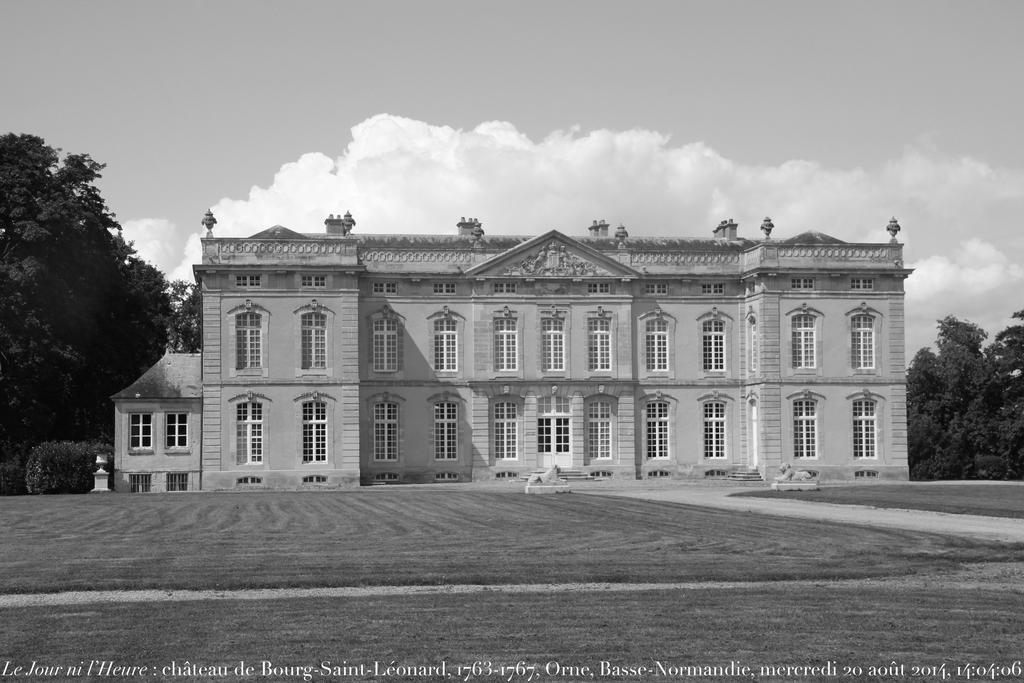How would you summarize this image in a sentence or two? In this picture we can see a building, at the bottom there is grass, on the right side and left side we can see trees, there is the sky and clouds at the top of the picture, we can see some text at the bottom, it is a black and white image. 